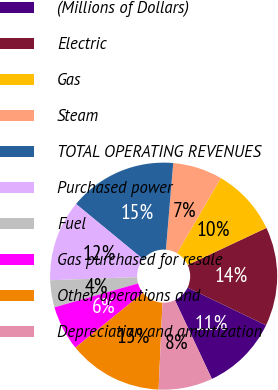Convert chart to OTSL. <chart><loc_0><loc_0><loc_500><loc_500><pie_chart><fcel>(Millions of Dollars)<fcel>Electric<fcel>Gas<fcel>Steam<fcel>TOTAL OPERATING REVENUES<fcel>Purchased power<fcel>Fuel<fcel>Gas purchased for resale<fcel>Other operations and<fcel>Depreciation and amortization<nl><fcel>10.9%<fcel>14.1%<fcel>9.62%<fcel>7.05%<fcel>15.38%<fcel>11.54%<fcel>3.85%<fcel>6.41%<fcel>13.46%<fcel>7.69%<nl></chart> 